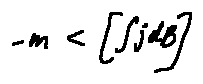<formula> <loc_0><loc_0><loc_500><loc_500>- m < [ \int j d B ]</formula> 